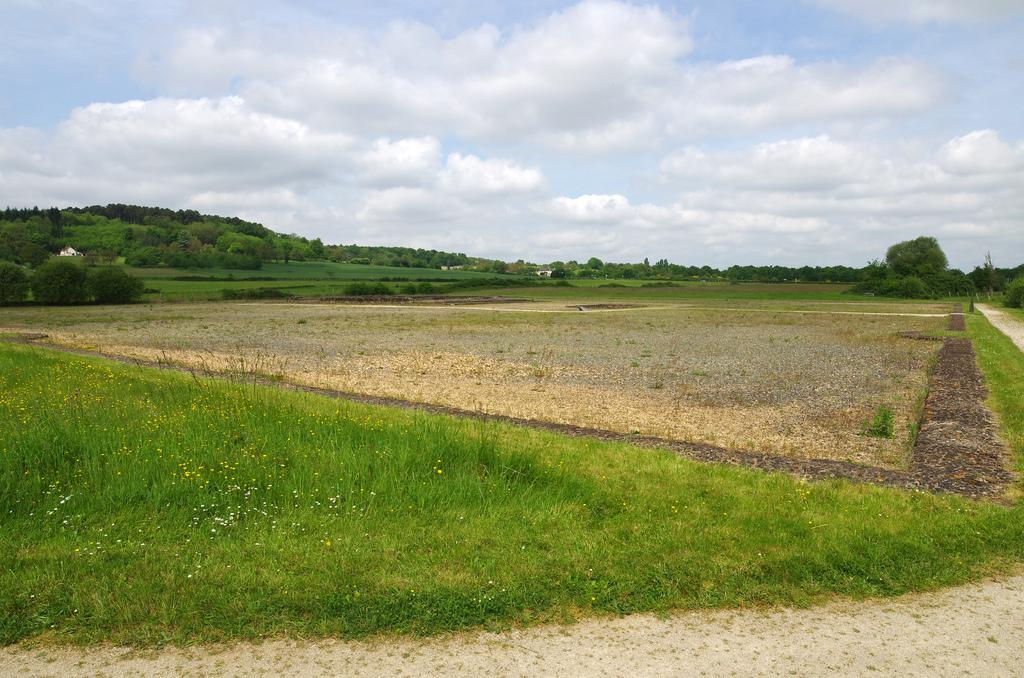What type of vegetation is present in the image? There is grass in the image. What other natural elements can be seen in the image? There are trees and mountains in the image. What is visible in the background of the image? The sky is visible in the image. What can be observed in the sky? There are clouds in the sky. What type of division is taking place in the image? There is no division taking place in the image; it is a natural scene featuring grass, trees, mountains, sky, and clouds. 